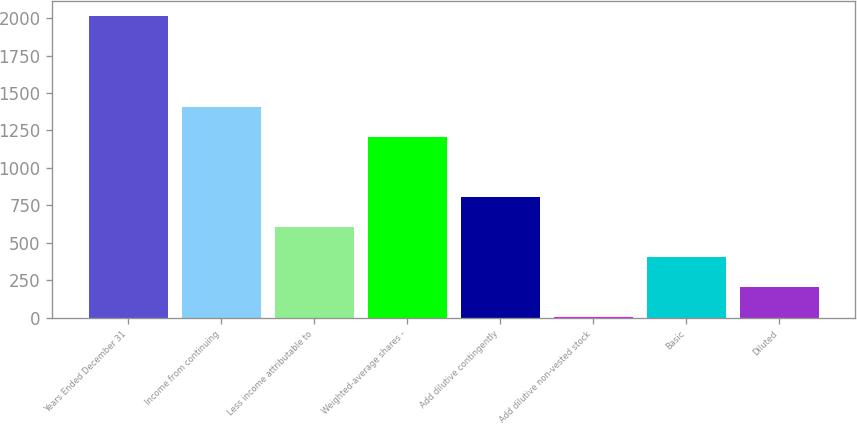<chart> <loc_0><loc_0><loc_500><loc_500><bar_chart><fcel>Years Ended December 31<fcel>Income from continuing<fcel>Less income attributable to<fcel>Weighted-average shares -<fcel>Add dilutive contingently<fcel>Add dilutive non-vested stock<fcel>Basic<fcel>Diluted<nl><fcel>2012<fcel>1408.73<fcel>604.37<fcel>1207.64<fcel>805.46<fcel>1.1<fcel>403.28<fcel>202.19<nl></chart> 